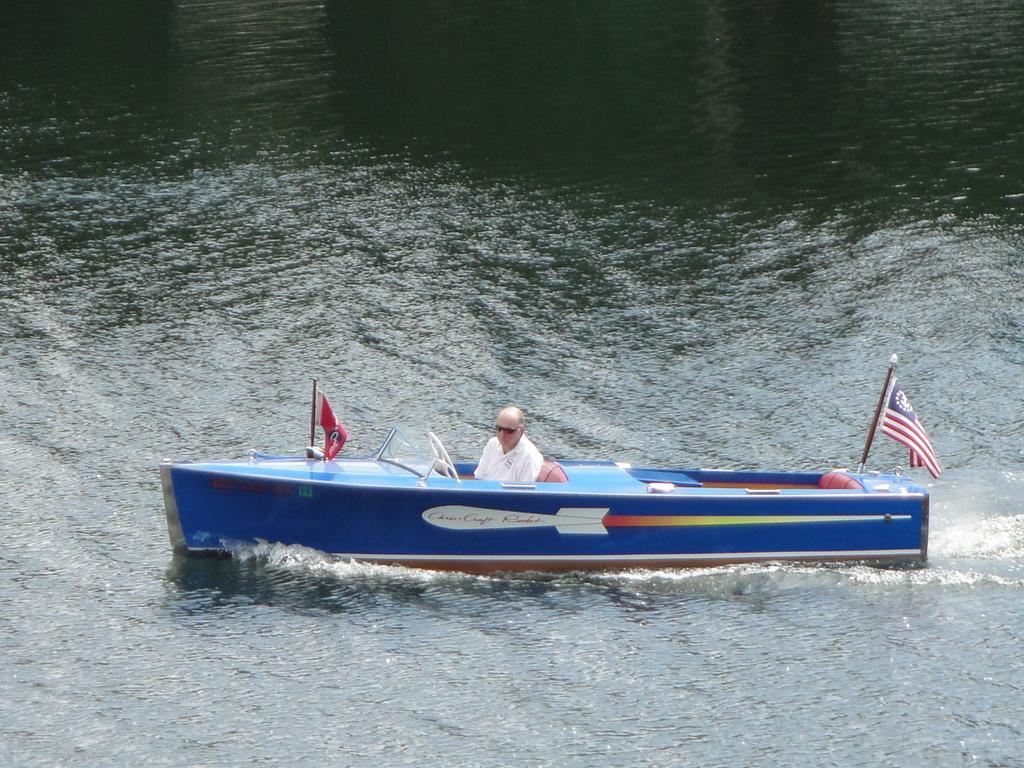Can you describe this image briefly? In this image we can see a man sailing a boat in the water. We can also see the flags attached to a boat. 